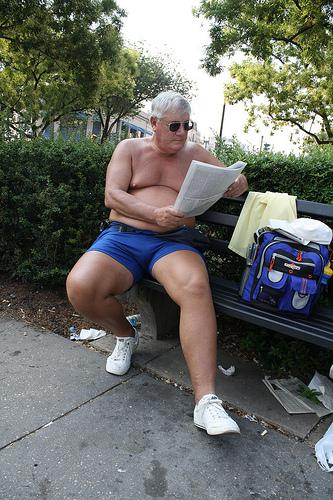Question: why is the man looking down?
Choices:
A. Checking time.
B. Tying shoe.
C. Fixing pants.
D. Reading.
Answer with the letter. Answer: D Question: how many people are in the picture?
Choices:
A. 2.
B. 4.
C. 1.
D. 5.
Answer with the letter. Answer: C Question: what is the man reading?
Choices:
A. Book.
B. Magazine.
C. EReader.
D. Newspaper.
Answer with the letter. Answer: D Question: who is in the picture?
Choices:
A. Woman.
B. Boy.
C. Girl.
D. Man.
Answer with the letter. Answer: D 